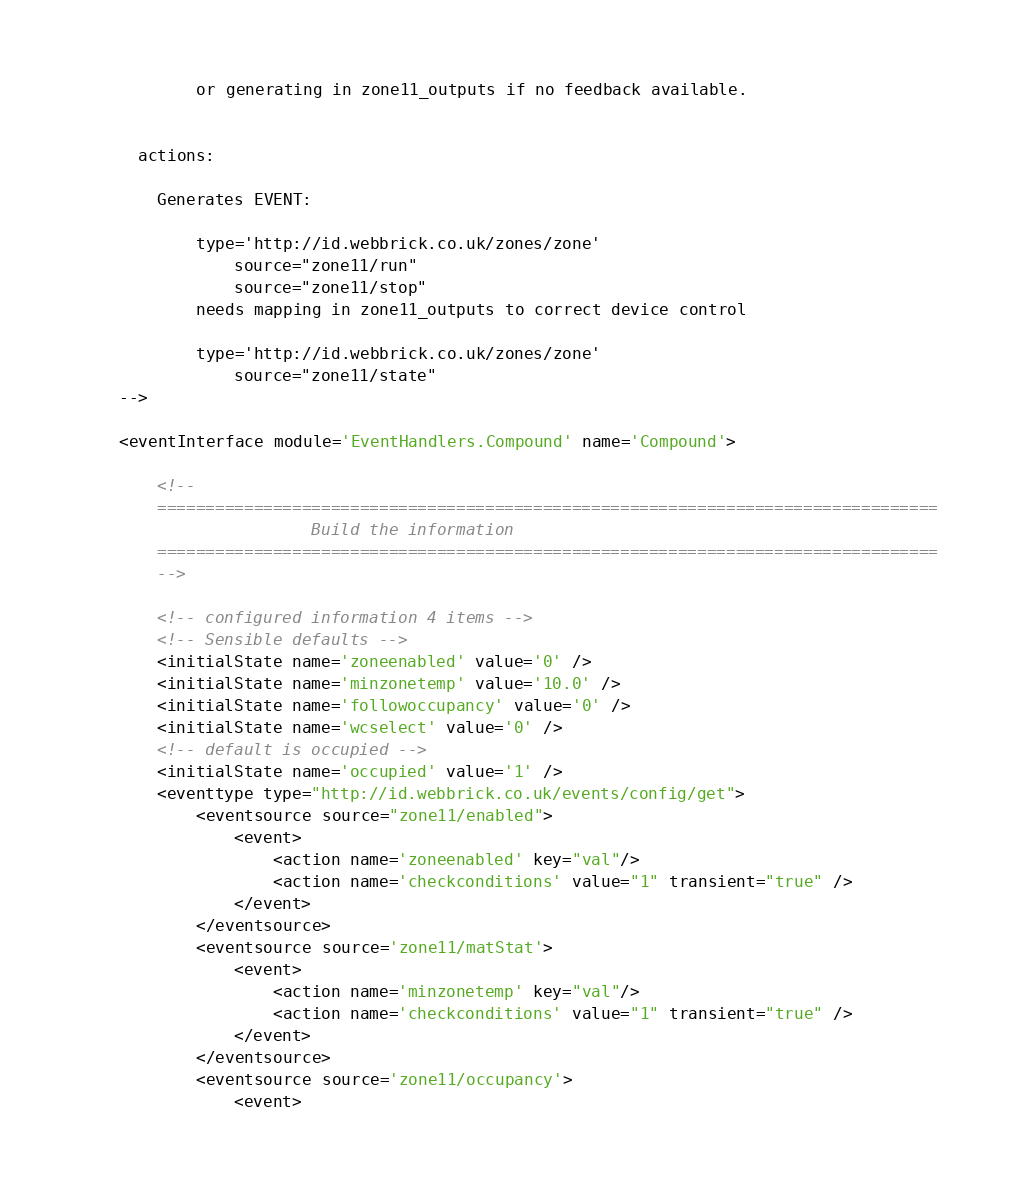<code> <loc_0><loc_0><loc_500><loc_500><_XML_>            or generating in zone11_outputs if no feedback available.
            
    
      actions:
      
        Generates EVENT:
           
            type='http://id.webbrick.co.uk/zones/zone' 
                source="zone11/run"
                source="zone11/stop"
            needs mapping in zone11_outputs to correct device control

            type='http://id.webbrick.co.uk/zones/zone' 
                source="zone11/state"
    -->

    <eventInterface module='EventHandlers.Compound' name='Compound'>

        <!--  
        =================================================================================
                        Build the information
        =================================================================================
        -->

        <!-- configured information 4 items -->
        <!-- Sensible defaults -->
        <initialState name='zoneenabled' value='0' />
        <initialState name='minzonetemp' value='10.0' />
        <initialState name='followoccupancy' value='0' />
        <initialState name='wcselect' value='0' />
        <!-- default is occupied -->
        <initialState name='occupied' value='1' />
        <eventtype type="http://id.webbrick.co.uk/events/config/get">
            <eventsource source="zone11/enabled">
                <event>
                    <action name='zoneenabled' key="val"/>
                    <action name='checkconditions' value="1" transient="true" />
                </event>
            </eventsource>
            <eventsource source='zone11/matStat'>
                <event>
                    <action name='minzonetemp' key="val"/>
                    <action name='checkconditions' value="1" transient="true" />
                </event>
            </eventsource>
            <eventsource source='zone11/occupancy'>
                <event></code> 